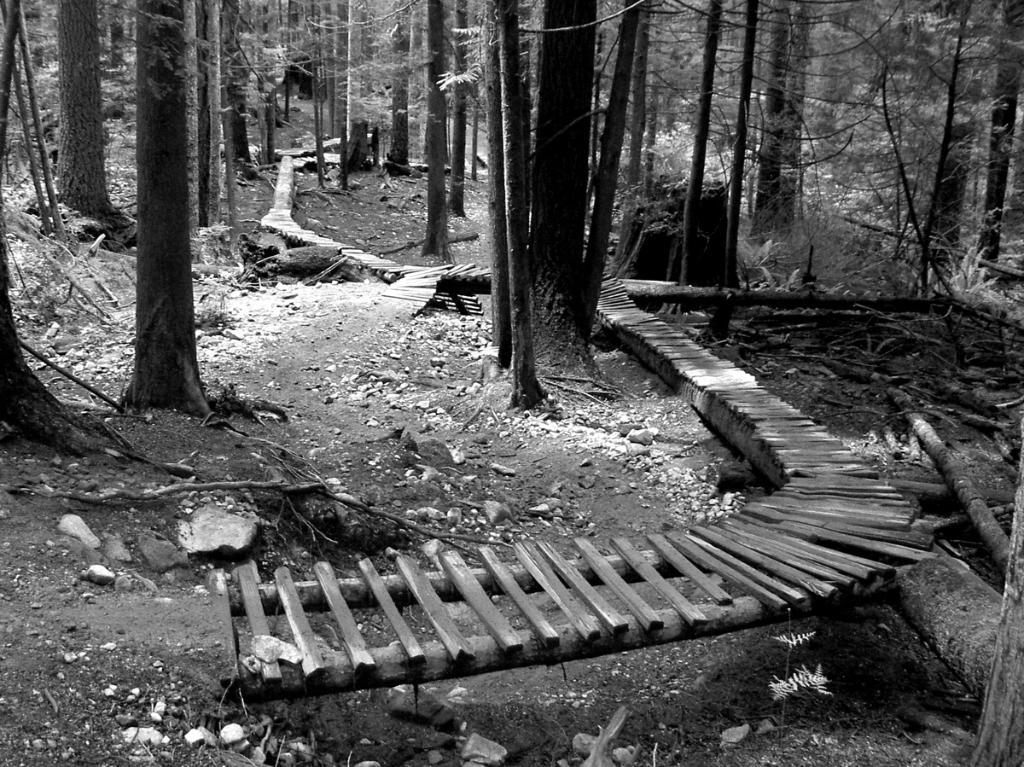What is the color scheme of the image? The image is black and white. What type of pathway can be seen in the image? There is a wooden pathway in the image. What type of vegetation is present in the image? There are trees in the image. What type of care is being provided to the bat in the image? There is no bat present in the image, so no care is being provided to a bat. What type of profit is being generated from the wooden pathway in the image? The image does not provide any information about profit generation, and there is no indication of any economic activity related to the wooden pathway. 